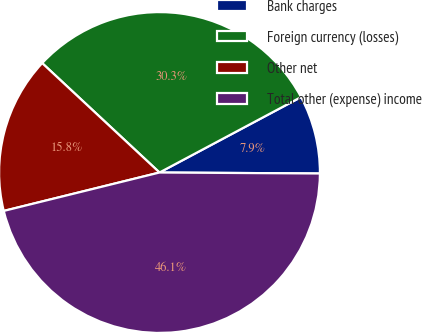Convert chart to OTSL. <chart><loc_0><loc_0><loc_500><loc_500><pie_chart><fcel>Bank charges<fcel>Foreign currency (losses)<fcel>Other net<fcel>Total other (expense) income<nl><fcel>7.89%<fcel>30.26%<fcel>15.79%<fcel>46.05%<nl></chart> 